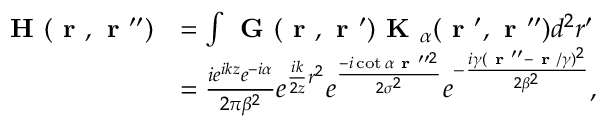<formula> <loc_0><loc_0><loc_500><loc_500>\begin{array} { r l } { H ( r , r ^ { \prime \prime } ) } & { = \int G ( r , r ^ { \prime } ) K _ { \alpha } ( r ^ { \prime } , r ^ { \prime \prime } ) d ^ { 2 } r ^ { \prime } } \\ & { = \frac { i e ^ { i k z } e ^ { - i \alpha } } { 2 \pi \beta ^ { 2 } } e ^ { \frac { i k } { 2 z } r ^ { 2 } } e ^ { \frac { - i \cot { \alpha } r ^ { \prime \prime 2 } } { 2 \sigma ^ { 2 } } } e ^ { - \frac { i \gamma ( r ^ { \prime \prime } - r / \gamma ) ^ { 2 } } { 2 \beta ^ { 2 } } } , } \end{array}</formula> 